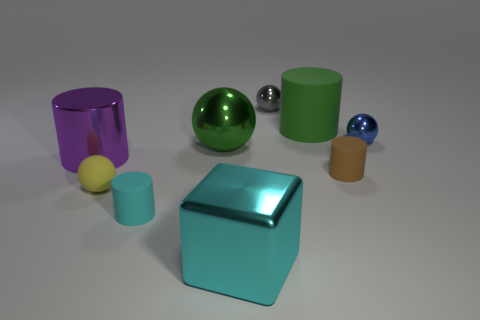There is a cylinder that is left of the small gray metallic thing and behind the small cyan cylinder; what material is it made of?
Make the answer very short. Metal. Is the size of the metallic object that is right of the brown rubber cylinder the same as the big green matte thing?
Your answer should be compact. No. Is there anything else that is the same size as the metallic cube?
Ensure brevity in your answer.  Yes. Is the number of cyan metallic blocks behind the green matte thing greater than the number of yellow matte spheres to the right of the cyan metallic object?
Your answer should be very brief. No. The large object that is in front of the large cylinder that is left of the tiny object that is left of the cyan rubber cylinder is what color?
Give a very brief answer. Cyan. Is the color of the metallic ball on the right side of the brown cylinder the same as the big rubber cylinder?
Keep it short and to the point. No. How many other objects are the same color as the large shiny cube?
Ensure brevity in your answer.  1. How many things are gray objects or cyan shiny things?
Your response must be concise. 2. How many objects are either yellow spheres or tiny cylinders that are to the right of the small cyan cylinder?
Make the answer very short. 2. Is the material of the green ball the same as the blue sphere?
Keep it short and to the point. Yes. 